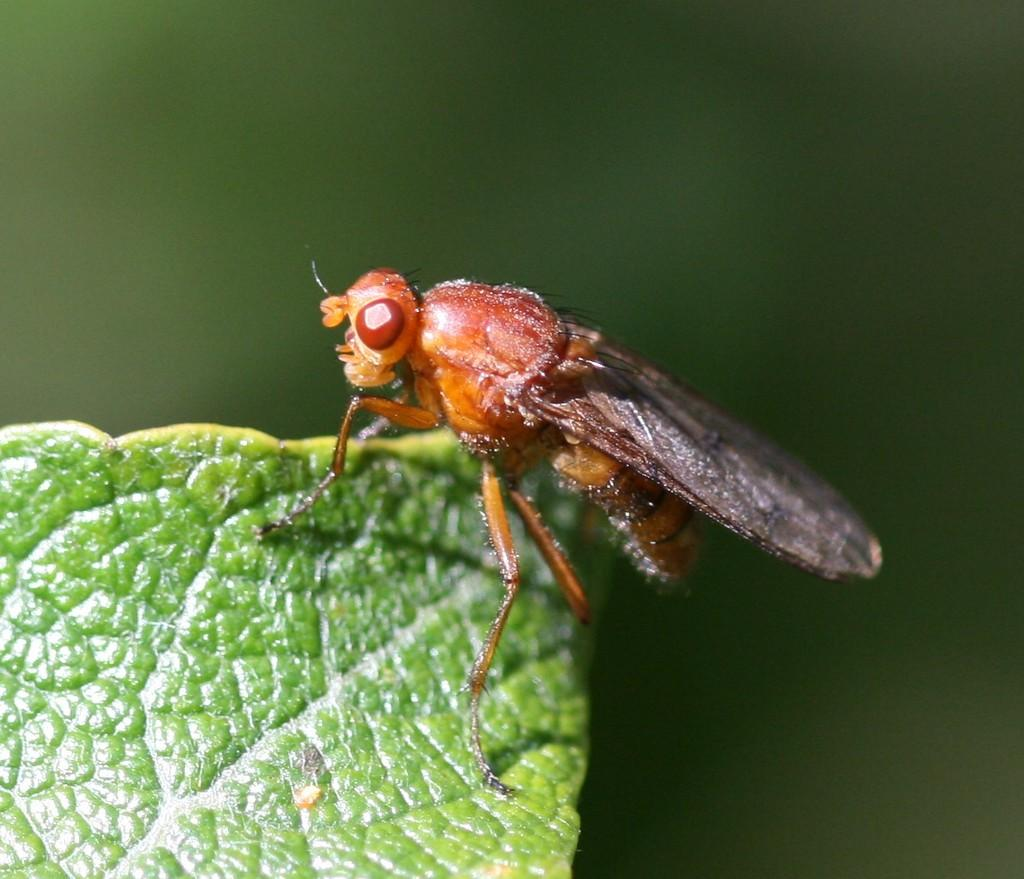What is present in the image? There is an insect in the image. Where is the insect located? The insect is on a leaf. Can you describe the background of the image? The background of the image is blurred. What type of adjustment does the insect need to make in order to hear better in the image? The insect does not need to make any adjustments to hear better in the image, as insects primarily use their antennae for sensing their environment rather than relying on hearing. 